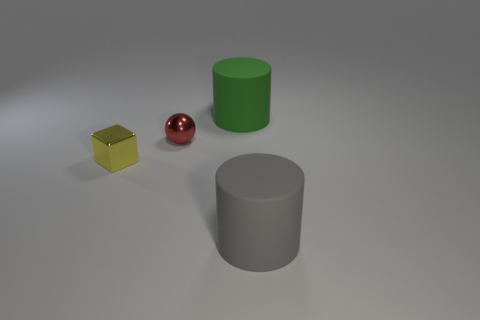Add 1 small cyan rubber objects. How many objects exist? 5 Subtract 1 spheres. How many spheres are left? 0 Subtract all green cylinders. How many cylinders are left? 1 Subtract all balls. How many objects are left? 3 Subtract all small blue balls. Subtract all small shiny spheres. How many objects are left? 3 Add 2 big gray cylinders. How many big gray cylinders are left? 3 Add 2 yellow objects. How many yellow objects exist? 3 Subtract 0 brown cylinders. How many objects are left? 4 Subtract all green cylinders. Subtract all yellow spheres. How many cylinders are left? 1 Subtract all red balls. How many green cylinders are left? 1 